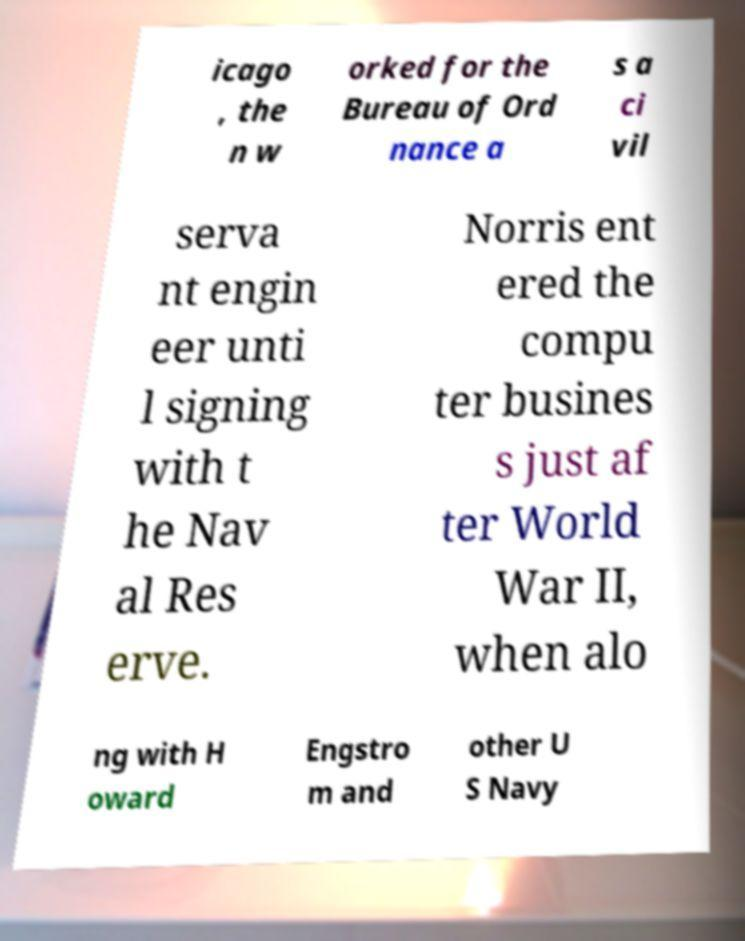Could you extract and type out the text from this image? icago , the n w orked for the Bureau of Ord nance a s a ci vil serva nt engin eer unti l signing with t he Nav al Res erve. Norris ent ered the compu ter busines s just af ter World War II, when alo ng with H oward Engstro m and other U S Navy 